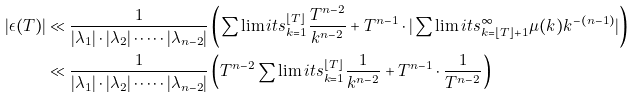Convert formula to latex. <formula><loc_0><loc_0><loc_500><loc_500>| \epsilon ( T ) | & \ll \frac { 1 } { | \lambda _ { 1 } | \cdot | \lambda _ { 2 } | \cdot \dots \cdot | \lambda _ { n - 2 } | } \left ( \sum \lim i t s _ { k = 1 } ^ { \lfloor T \rfloor } \frac { T ^ { n - 2 } } { k ^ { n - 2 } } + T ^ { n - 1 } \cdot | \sum \lim i t s _ { k = \lfloor T \rfloor + 1 } ^ { \infty } \mu ( k ) { k } ^ { - ( n - 1 ) } | \right ) \\ & \ll \frac { 1 } { | \lambda _ { 1 } | \cdot | \lambda _ { 2 } | \cdot \dots \cdot | \lambda _ { n - 2 } | } \left ( T ^ { n - 2 } \sum \lim i t s _ { k = 1 } ^ { \lfloor T \rfloor } \frac { 1 } { k ^ { n - 2 } } + T ^ { n - 1 } \cdot \frac { 1 } { T ^ { n - 2 } } \right ) \\</formula> 